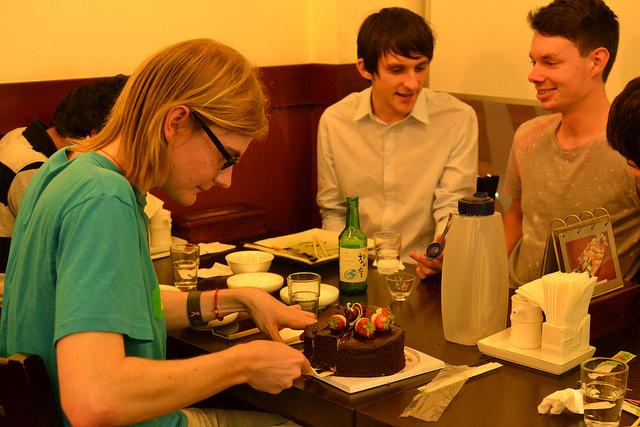Is everyone in this scene enjoying the conversation?
Keep it brief. Yes. How many men are here?
Quick response, please. 2. Is she wearing glasses?
Write a very short answer. Yes. What is the female cutting into?
Quick response, please. Cake. 